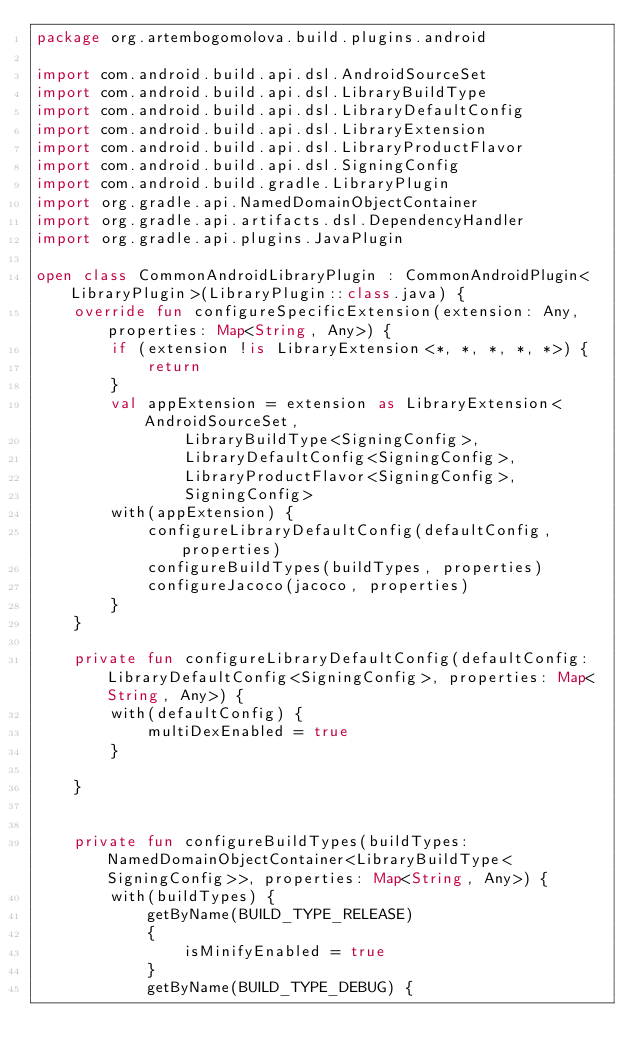Convert code to text. <code><loc_0><loc_0><loc_500><loc_500><_Kotlin_>package org.artembogomolova.build.plugins.android

import com.android.build.api.dsl.AndroidSourceSet
import com.android.build.api.dsl.LibraryBuildType
import com.android.build.api.dsl.LibraryDefaultConfig
import com.android.build.api.dsl.LibraryExtension
import com.android.build.api.dsl.LibraryProductFlavor
import com.android.build.api.dsl.SigningConfig
import com.android.build.gradle.LibraryPlugin
import org.gradle.api.NamedDomainObjectContainer
import org.gradle.api.artifacts.dsl.DependencyHandler
import org.gradle.api.plugins.JavaPlugin

open class CommonAndroidLibraryPlugin : CommonAndroidPlugin<LibraryPlugin>(LibraryPlugin::class.java) {
    override fun configureSpecificExtension(extension: Any, properties: Map<String, Any>) {
        if (extension !is LibraryExtension<*, *, *, *, *>) {
            return
        }
        val appExtension = extension as LibraryExtension<AndroidSourceSet,
                LibraryBuildType<SigningConfig>,
                LibraryDefaultConfig<SigningConfig>,
                LibraryProductFlavor<SigningConfig>,
                SigningConfig>
        with(appExtension) {
            configureLibraryDefaultConfig(defaultConfig, properties)
            configureBuildTypes(buildTypes, properties)
            configureJacoco(jacoco, properties)
        }
    }

    private fun configureLibraryDefaultConfig(defaultConfig: LibraryDefaultConfig<SigningConfig>, properties: Map<String, Any>) {
        with(defaultConfig) {
            multiDexEnabled = true
        }

    }


    private fun configureBuildTypes(buildTypes: NamedDomainObjectContainer<LibraryBuildType<SigningConfig>>, properties: Map<String, Any>) {
        with(buildTypes) {
            getByName(BUILD_TYPE_RELEASE)
            {
                isMinifyEnabled = true
            }
            getByName(BUILD_TYPE_DEBUG) {</code> 